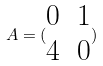Convert formula to latex. <formula><loc_0><loc_0><loc_500><loc_500>A = ( \begin{matrix} 0 & 1 \\ 4 & 0 \end{matrix} )</formula> 